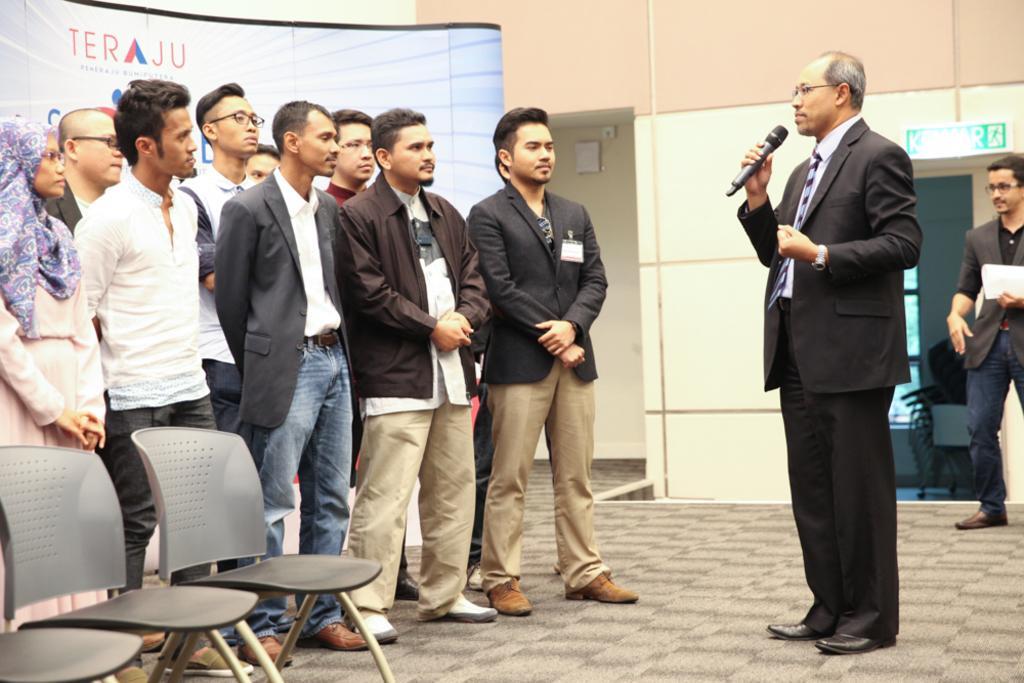In one or two sentences, can you explain what this image depicts? In this image there are people standing on a floor one man is holding a mike in his hand, in the bottom left there are chairs, in the background there is a wall, for that wall there is a door and a banner, on that banner there is some text. 